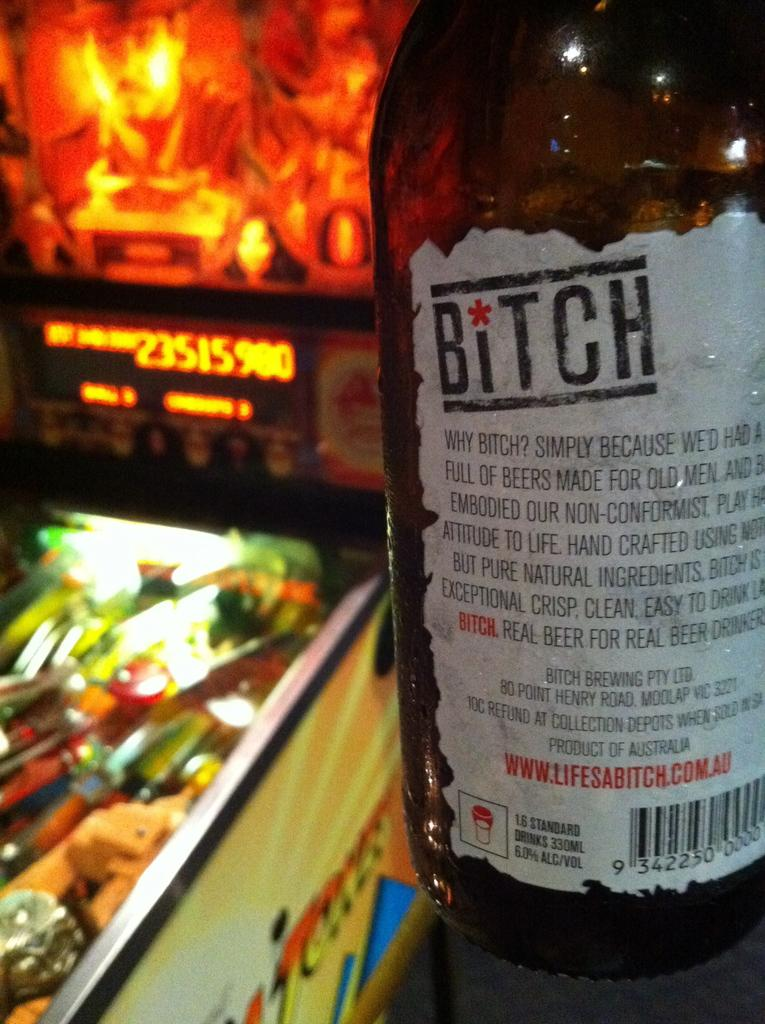<image>
Create a compact narrative representing the image presented. A bottle of Bitch beer is showing the label as to why its named Bitch 